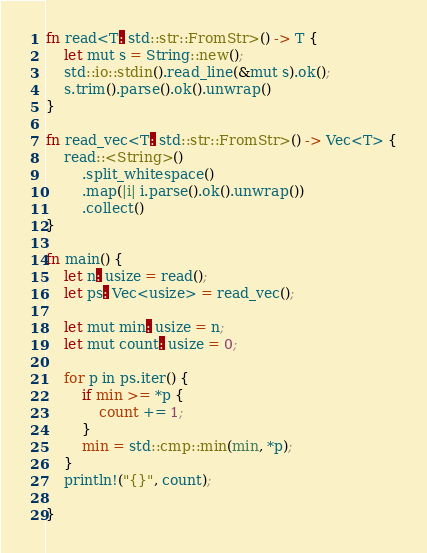<code> <loc_0><loc_0><loc_500><loc_500><_Clojure_>fn read<T: std::str::FromStr>() -> T {
    let mut s = String::new();
    std::io::stdin().read_line(&mut s).ok();
    s.trim().parse().ok().unwrap()
}

fn read_vec<T: std::str::FromStr>() -> Vec<T> {
    read::<String>()
        .split_whitespace()
        .map(|i| i.parse().ok().unwrap())
        .collect()
}

fn main() {
    let n: usize = read();
    let ps: Vec<usize> = read_vec();

    let mut min: usize = n;
    let mut count: usize = 0;

    for p in ps.iter() {
        if min >= *p {
            count += 1;
        }
        min = std::cmp::min(min, *p);
    }
    println!("{}", count);

}</code> 